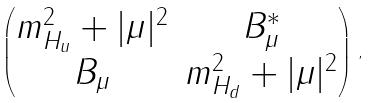<formula> <loc_0><loc_0><loc_500><loc_500>\begin{pmatrix} m _ { H _ { u } } ^ { 2 } + | \mu | ^ { 2 } & B _ { \mu } ^ { * } \\ B _ { \mu } & m _ { H _ { d } } ^ { 2 } + | \mu | ^ { 2 } \end{pmatrix} \, ,</formula> 